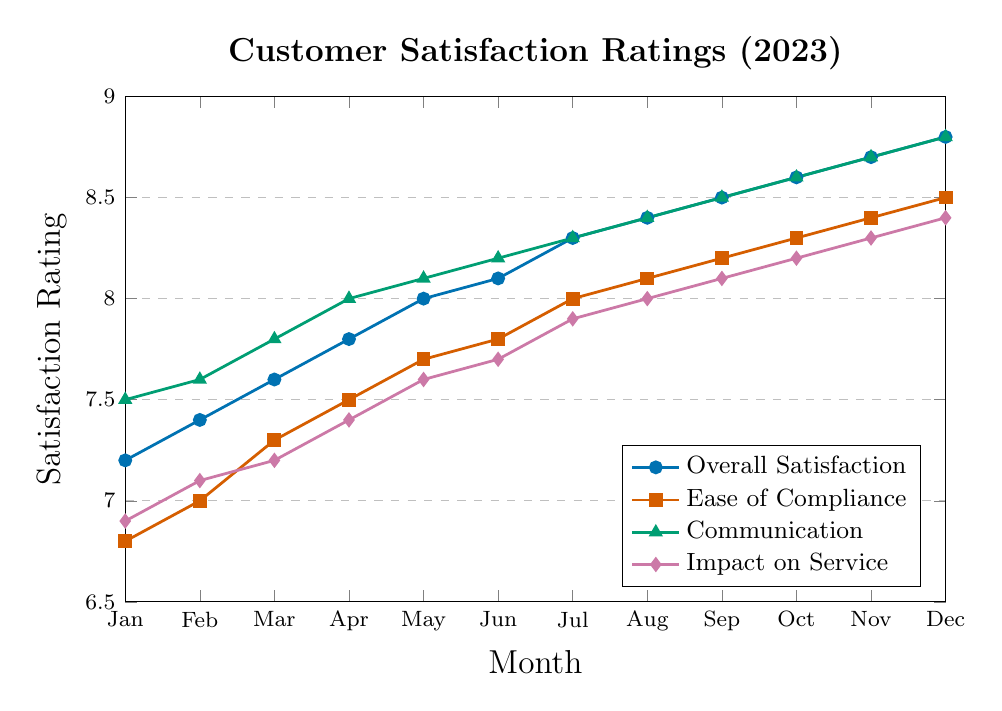How has the Overall Satisfaction rating changed from January to December 2023? First, locate the Overall Satisfaction rating for January and December. January's rating is 7.2, and December's rating is 8.8. Subtract January's rating from December's rating: 8.8 - 7.2 = 1.6
Answer: It increased by 1.6 Which satisfaction category had the highest rating in July 2023? Locate the ratings for all categories in July 2023. Overall Satisfaction is 8.3, Ease of Compliance is 8.0, Communication is 8.3, and Impact on Service is 7.9. Both Overall Satisfaction and Communication have the highest rating of 8.3
Answer: Overall Satisfaction and Communication What is the average rating for Ease of Compliance across the year? Sum the Ease of Compliance ratings from January to December: 6.8 + 7.0 + 7.3 + 7.5 + 7.7 + 7.8 + 8.0 + 8.1 + 8.2 + 8.3 + 8.4 + 8.5 = 93.6. Divide by the number of months (12): 93.6 / 12 = 7.8
Answer: 7.8 In which month did Impact on Service reach 8.0 for the first time? Scan the Impact on Service ratings from January to December. The rating first reaches 8.0 in August 2023
Answer: August 2023 How did the rating for Communication change from June to July 2023? Locate the Communication ratings for June (8.2) and July (8.3). Subtract June's rating from July's rating: 8.3 - 8.2 = 0.1
Answer: Increased by 0.1 What was the trend of Ease of Compliance from January to June 2023? Observe the Ease of Compliance ratings from January to June: 6.8, 7.0, 7.3, 7.5, 7.7, 7.8. The ratings are steadily increasing each month
Answer: Increasing Which satisfaction category consistently had the lowest ratings across all months? Compare the ratings of all categories from January to December. Impact on Service ratings are generally the lowest each month
Answer: Impact on Service 